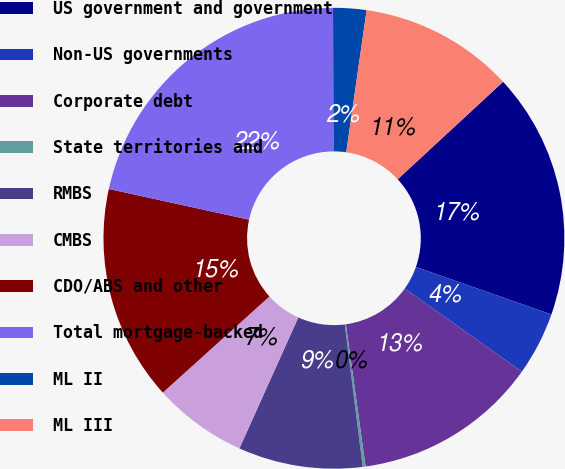Convert chart to OTSL. <chart><loc_0><loc_0><loc_500><loc_500><pie_chart><fcel>US government and government<fcel>Non-US governments<fcel>Corporate debt<fcel>State territories and<fcel>RMBS<fcel>CMBS<fcel>CDO/ABS and other<fcel>Total mortgage-backed<fcel>ML II<fcel>ML III<nl><fcel>17.24%<fcel>4.46%<fcel>12.98%<fcel>0.2%<fcel>8.72%<fcel>6.59%<fcel>15.11%<fcel>21.5%<fcel>2.33%<fcel>10.85%<nl></chart> 